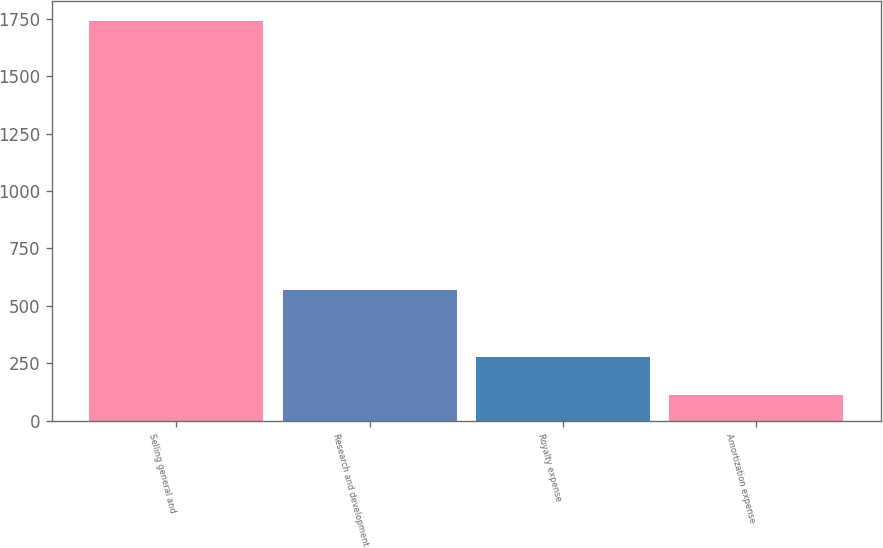<chart> <loc_0><loc_0><loc_500><loc_500><bar_chart><fcel>Selling general and<fcel>Research and development<fcel>Royalty expense<fcel>Amortization expense<nl><fcel>1742<fcel>569<fcel>275<fcel>112<nl></chart> 